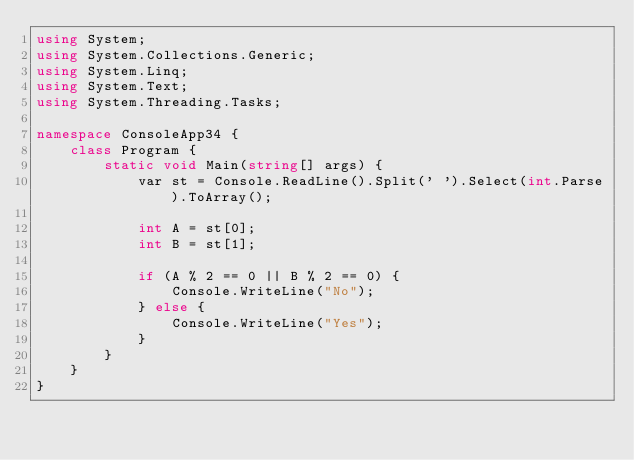Convert code to text. <code><loc_0><loc_0><loc_500><loc_500><_C#_>using System;
using System.Collections.Generic;
using System.Linq;
using System.Text;
using System.Threading.Tasks;

namespace ConsoleApp34 {
    class Program {
        static void Main(string[] args) {
            var st = Console.ReadLine().Split(' ').Select(int.Parse).ToArray();

            int A = st[0];
            int B = st[1];

            if (A % 2 == 0 || B % 2 == 0) {
                Console.WriteLine("No");
            } else {
                Console.WriteLine("Yes");
            }
        }
    }
}
</code> 